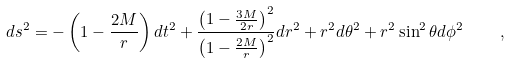Convert formula to latex. <formula><loc_0><loc_0><loc_500><loc_500>d s ^ { 2 } = - \left ( 1 - \frac { 2 M } { r } \right ) d t ^ { 2 } + \frac { \left ( 1 - \frac { 3 M } { 2 r } \right ) ^ { 2 } } { \left ( 1 - \frac { 2 M } { r } \right ) ^ { 2 } } d r ^ { 2 } + r ^ { 2 } d \theta ^ { 2 } + r ^ { 2 } \sin ^ { 2 } \theta d \phi ^ { 2 } \quad ,</formula> 